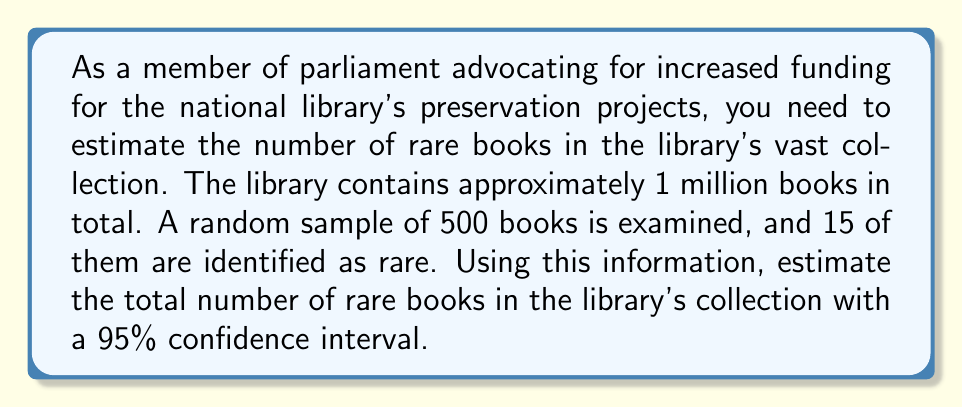Can you solve this math problem? To solve this problem, we'll use the confidence interval for a proportion. The steps are as follows:

1) First, let's identify our variables:
   $n$ = sample size = 500
   $\hat{p}$ = sample proportion = 15/500 = 0.03
   $N$ = population size = 1,000,000
   Confidence level = 95% (z-score = 1.96)

2) The formula for the confidence interval of a proportion is:

   $$\hat{p} \pm z\sqrt{\frac{\hat{p}(1-\hat{p})}{n}\cdot\frac{N-n}{N-1}}$$

3) Let's calculate the margin of error:

   $$\text{ME} = 1.96\sqrt{\frac{0.03(1-0.03)}{500}\cdot\frac{1,000,000-500}{1,000,000-1}}$$
   
   $$= 1.96\sqrt{0.0291\cdot0.0009995} = 1.96\sqrt{0.00002909} = 1.96(0.00539) = 0.01056$$

4) Now we can calculate the confidence interval for the proportion:

   Lower bound: $0.03 - 0.01056 = 0.01944$
   Upper bound: $0.03 + 0.01056 = 0.04056$

5) To estimate the number of rare books, we multiply these proportions by the total number of books:

   Lower estimate: $0.01944 \times 1,000,000 = 19,440$
   Upper estimate: $0.04056 \times 1,000,000 = 40,560$

Therefore, we can estimate with 95% confidence that the number of rare books in the library's collection is between 19,440 and 40,560.
Answer: The estimated number of rare books in the library's collection is between 19,440 and 40,560, with 95% confidence. 